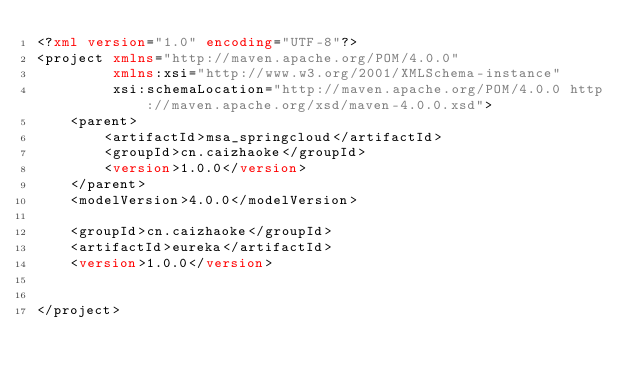Convert code to text. <code><loc_0><loc_0><loc_500><loc_500><_XML_><?xml version="1.0" encoding="UTF-8"?>
<project xmlns="http://maven.apache.org/POM/4.0.0"
         xmlns:xsi="http://www.w3.org/2001/XMLSchema-instance"
         xsi:schemaLocation="http://maven.apache.org/POM/4.0.0 http://maven.apache.org/xsd/maven-4.0.0.xsd">
    <parent>
        <artifactId>msa_springcloud</artifactId>
        <groupId>cn.caizhaoke</groupId>
        <version>1.0.0</version>
    </parent>
    <modelVersion>4.0.0</modelVersion>

    <groupId>cn.caizhaoke</groupId>
    <artifactId>eureka</artifactId>
    <version>1.0.0</version>


</project></code> 